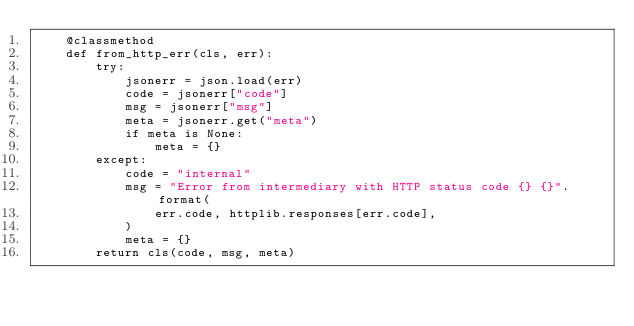Convert code to text. <code><loc_0><loc_0><loc_500><loc_500><_Python_>    @classmethod
    def from_http_err(cls, err):
        try:
            jsonerr = json.load(err)
            code = jsonerr["code"]
            msg = jsonerr["msg"]
            meta = jsonerr.get("meta")
            if meta is None:
                meta = {}
        except:
            code = "internal"
            msg = "Error from intermediary with HTTP status code {} {}".format(
                err.code, httplib.responses[err.code],
            )
            meta = {}
        return cls(code, msg, meta)

</code> 